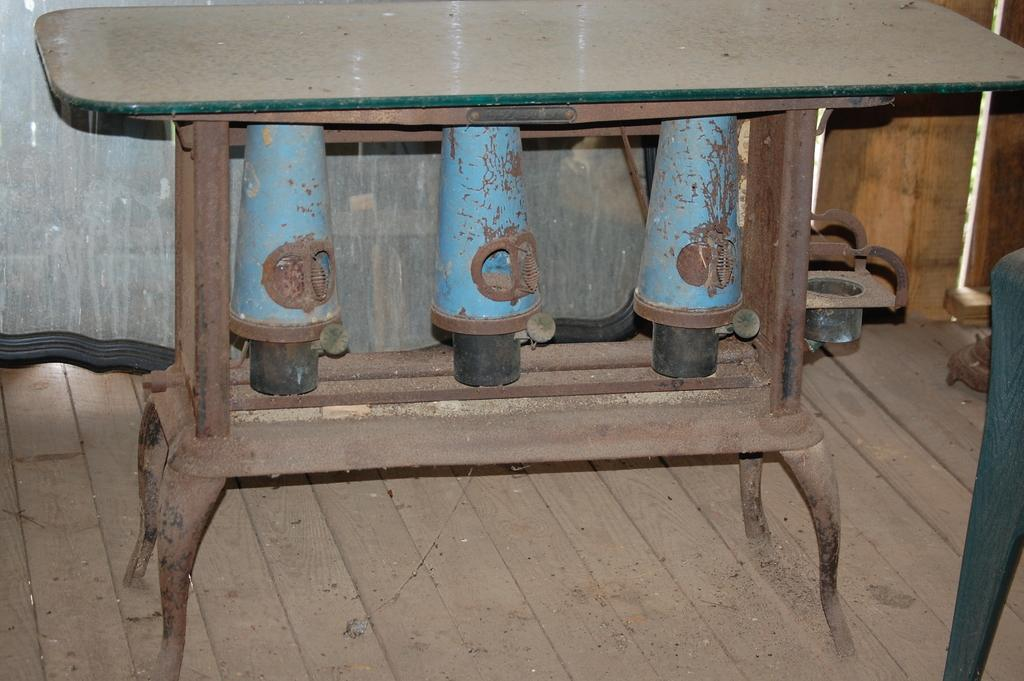What is the main object in the image? There is a table in the image. What is the table placed on? The table is on a wooden surface. What can be seen on the table? There is a glass on the table. How does the boat affect the growth of the match in the image? There is no boat or match present in the image, so this question cannot be answered. 